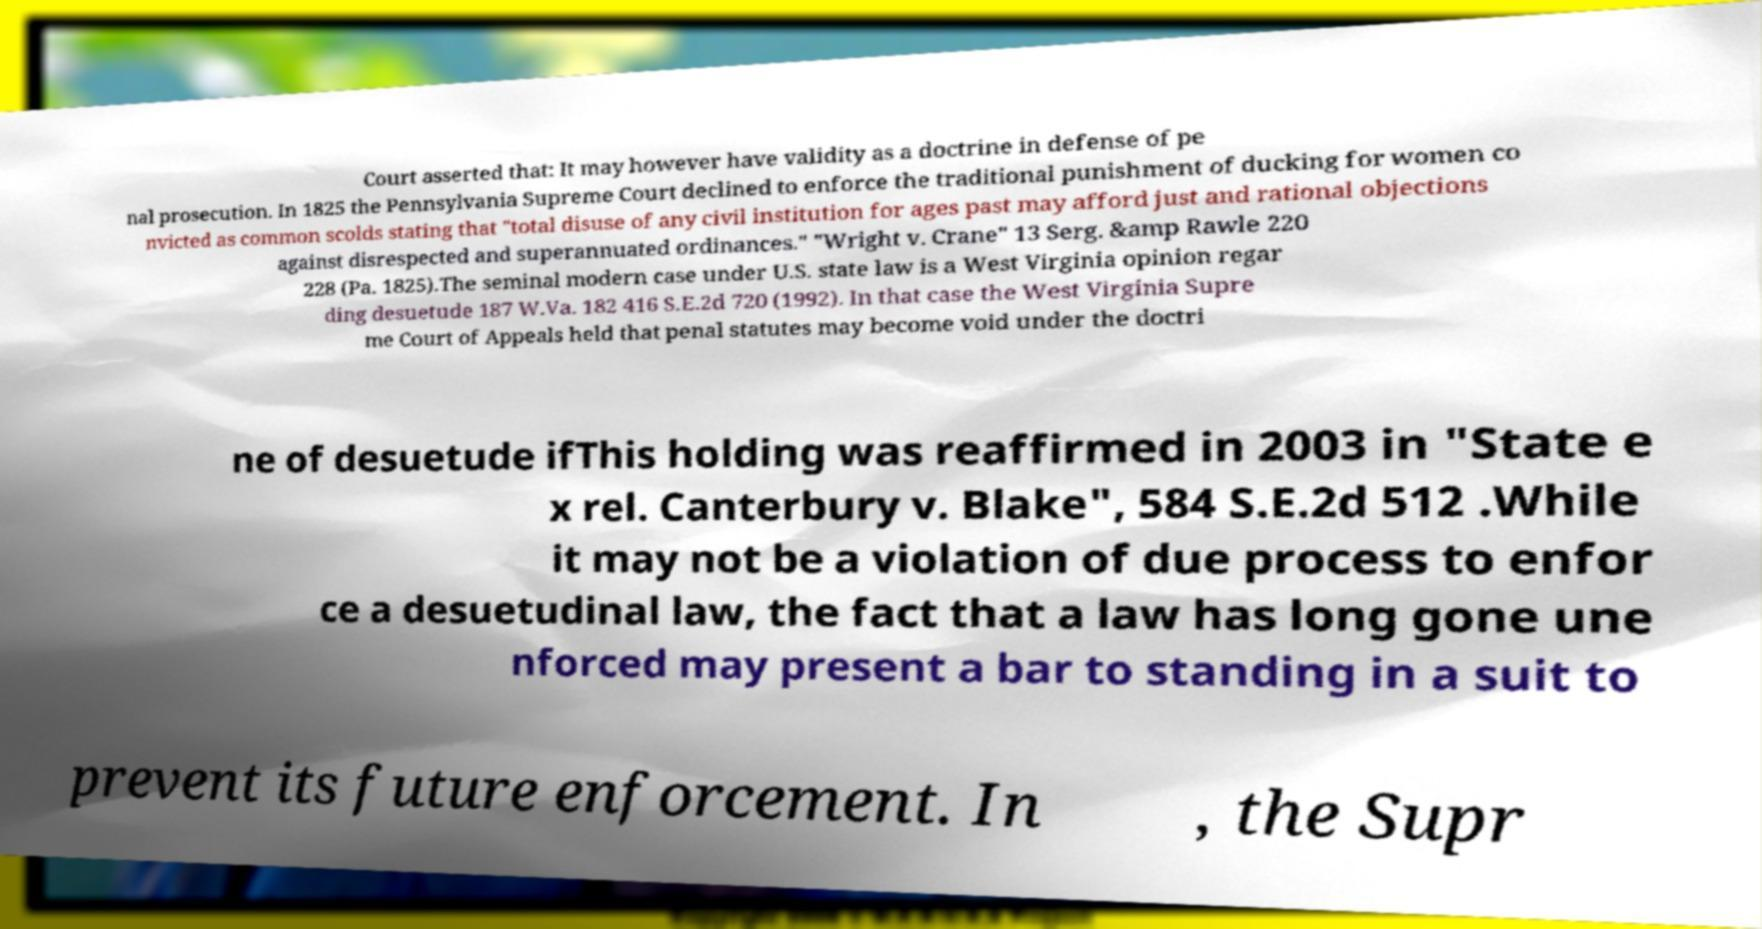What messages or text are displayed in this image? I need them in a readable, typed format. Court asserted that: It may however have validity as a doctrine in defense of pe nal prosecution. In 1825 the Pennsylvania Supreme Court declined to enforce the traditional punishment of ducking for women co nvicted as common scolds stating that "total disuse of any civil institution for ages past may afford just and rational objections against disrespected and superannuated ordinances." "Wright v. Crane" 13 Serg. &amp Rawle 220 228 (Pa. 1825).The seminal modern case under U.S. state law is a West Virginia opinion regar ding desuetude 187 W.Va. 182 416 S.E.2d 720 (1992). In that case the West Virginia Supre me Court of Appeals held that penal statutes may become void under the doctri ne of desuetude ifThis holding was reaffirmed in 2003 in "State e x rel. Canterbury v. Blake", 584 S.E.2d 512 .While it may not be a violation of due process to enfor ce a desuetudinal law, the fact that a law has long gone une nforced may present a bar to standing in a suit to prevent its future enforcement. In , the Supr 